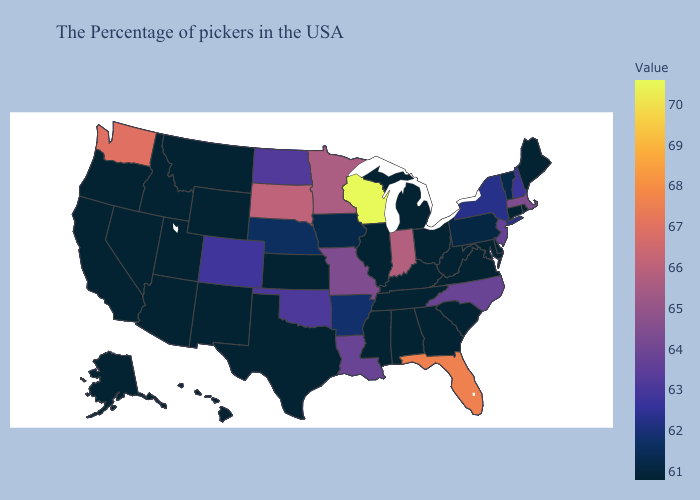Which states have the lowest value in the USA?
Quick response, please. Maine, Rhode Island, Connecticut, Delaware, Maryland, Virginia, South Carolina, West Virginia, Ohio, Georgia, Michigan, Kentucky, Alabama, Tennessee, Illinois, Mississippi, Kansas, Texas, Wyoming, New Mexico, Utah, Montana, Arizona, Idaho, Nevada, California, Oregon, Alaska, Hawaii. Which states hav the highest value in the MidWest?
Quick response, please. Wisconsin. Which states have the highest value in the USA?
Answer briefly. Wisconsin. Which states hav the highest value in the MidWest?
Short answer required. Wisconsin. Does Iowa have the lowest value in the USA?
Quick response, please. No. Among the states that border Connecticut , does Massachusetts have the highest value?
Concise answer only. Yes. 